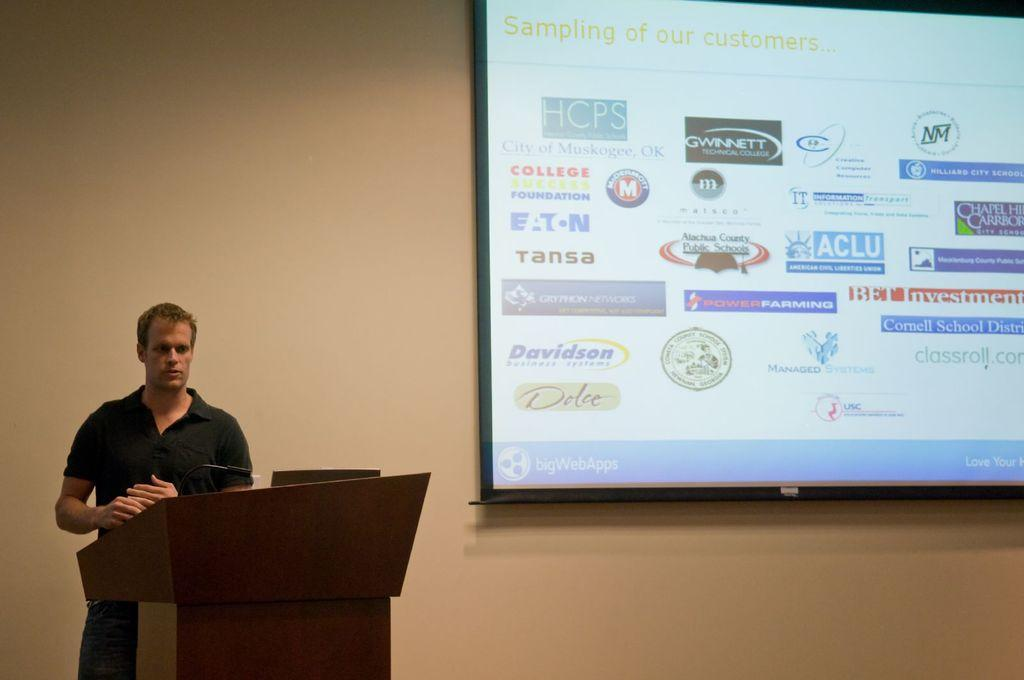What is the man doing in the image? The man is standing on the left side of the image. What is in front of the man? There is a podium in front of the man. What can be seen in the background of the image? There is a screen and a wall in the background of the image. How many fingers can be seen on the man's hand in the image? There is no information about the man's fingers in the provided facts, so it cannot be determined from the image. 